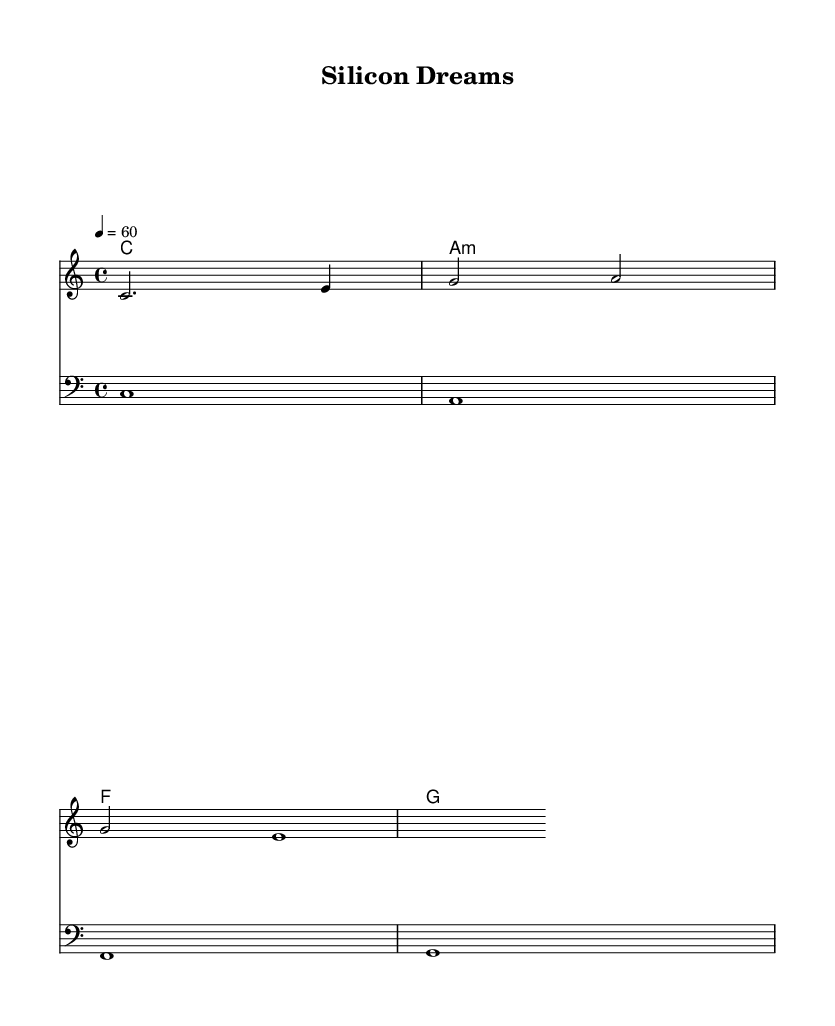What is the key signature of this music? The key signature is C major, which has no sharps or flats.
Answer: C major What is the time signature of this music? The time signature is indicated with a 4 on top of a 4, meaning there are four beats in each measure and the quarter note gets one beat.
Answer: 4/4 What is the tempo marking of this piece? The tempo is indicated by the number 60, which means 60 beats per minute.
Answer: 60 Which chord is played in the first measure? The first measure shows a C major chord, indicated by the written note C in the bass line and also in the chord names.
Answer: C How many measures are there in the melody? The melody consists of 3 measures as indicated by the structure of the notes written in the mainMelody section.
Answer: 3 What are the first three notes of the melody? The first three notes are C, E, and G, which can be deduced from the mainMelody line.
Answer: C, E, G Which element of the score represents the harmony? The chord names listed above the staves represent the harmonies played alongside the melody and bass line.
Answer: ChordNames 